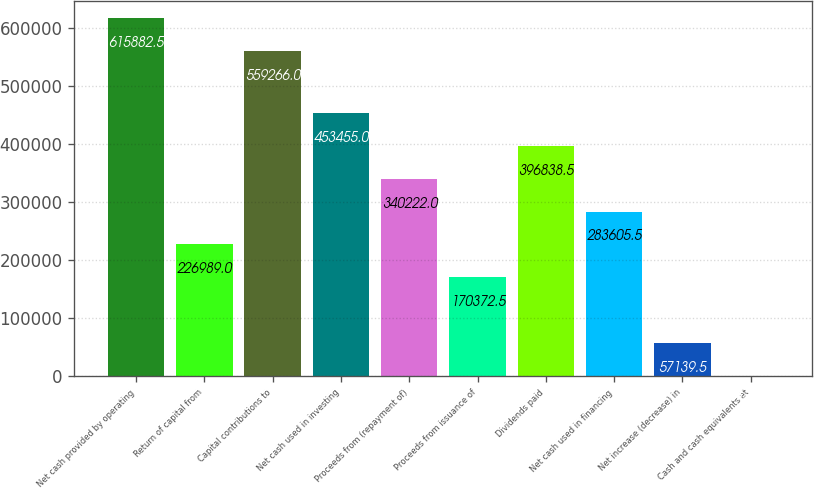Convert chart to OTSL. <chart><loc_0><loc_0><loc_500><loc_500><bar_chart><fcel>Net cash provided by operating<fcel>Return of capital from<fcel>Capital contributions to<fcel>Net cash used in investing<fcel>Proceeds from (repayment of)<fcel>Proceeds from issuance of<fcel>Dividends paid<fcel>Net cash used in financing<fcel>Net increase (decrease) in<fcel>Cash and cash equivalents at<nl><fcel>615882<fcel>226989<fcel>559266<fcel>453455<fcel>340222<fcel>170372<fcel>396838<fcel>283606<fcel>57139.5<fcel>523<nl></chart> 